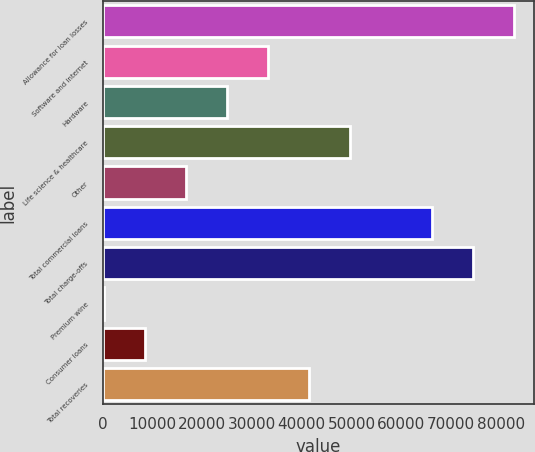Convert chart. <chart><loc_0><loc_0><loc_500><loc_500><bar_chart><fcel>Allowance for loan losses<fcel>Software and internet<fcel>Hardware<fcel>Life science & healthcare<fcel>Other<fcel>Total commercial loans<fcel>Total charge-offs<fcel>Premium wine<fcel>Consumer loans<fcel>Total recoveries<nl><fcel>82627<fcel>33184<fcel>24943.5<fcel>49665<fcel>16703<fcel>66146<fcel>74386.5<fcel>222<fcel>8462.5<fcel>41424.5<nl></chart> 